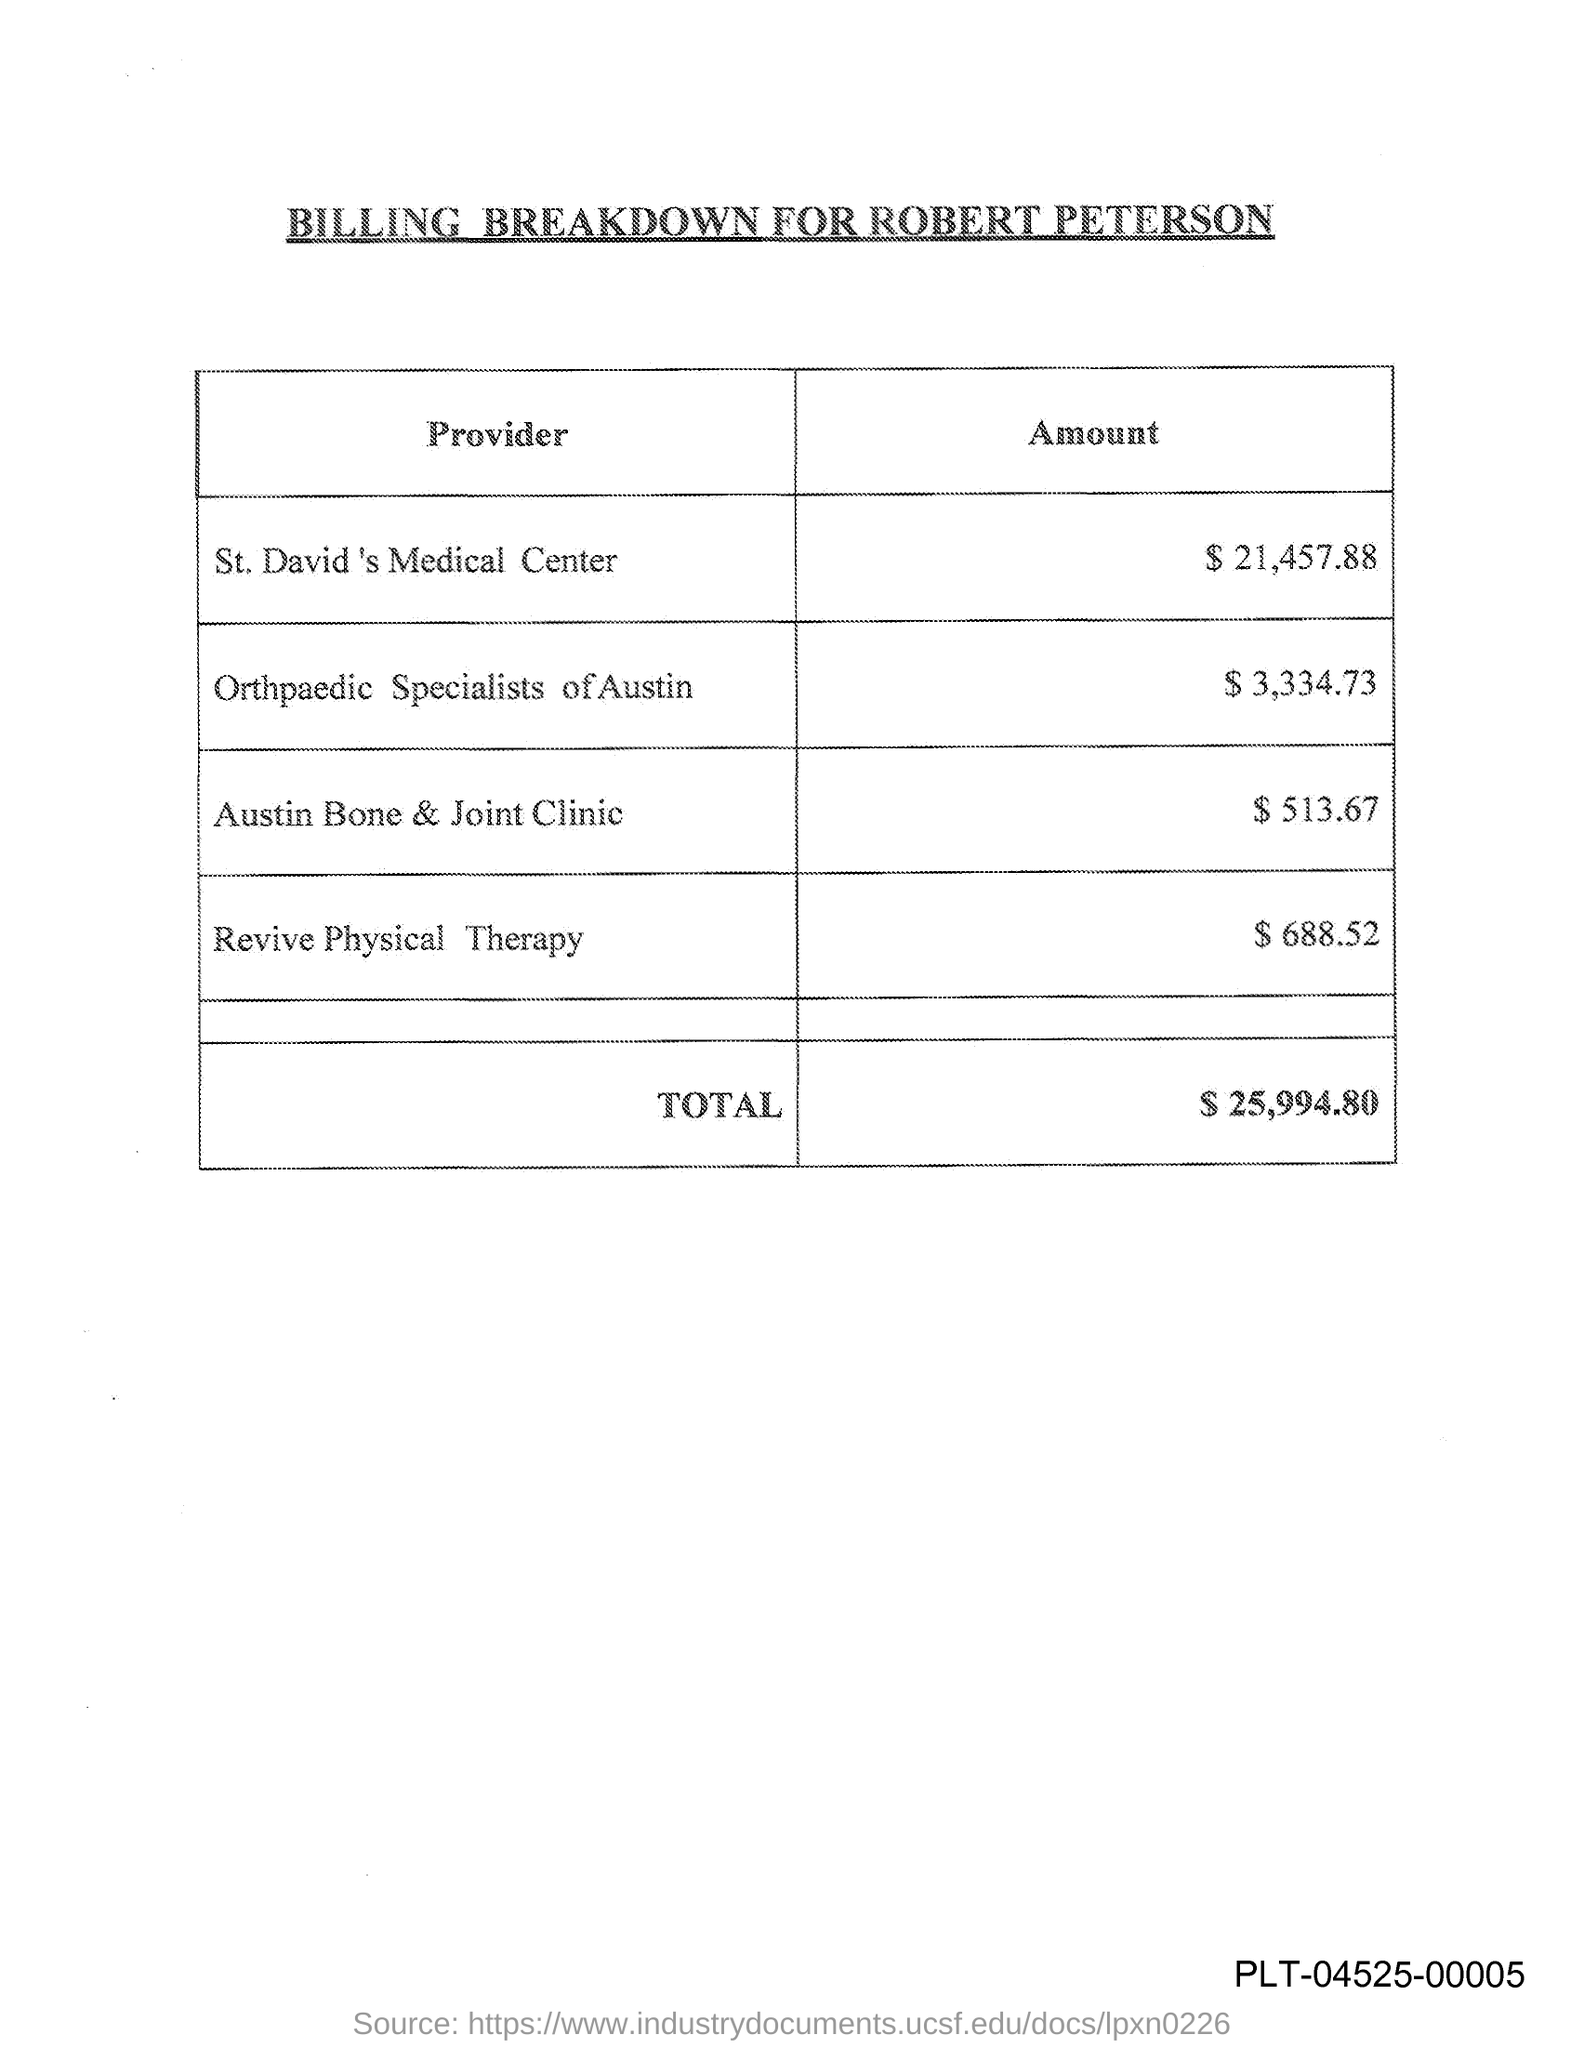What is the title of this document?
Your answer should be very brief. BILLING BREAKDOWN FOR ROBERT PETERSON. What is the amount provided by St. David's Medical Center?
Make the answer very short. $21,457.88. What is the amount provided by Revive Physical Therapy?
Ensure brevity in your answer.  $688.52. What is the amount provided by Orthopaedic Specialists of Austin?
Keep it short and to the point. $3,334.73. What is the total amount given in the document?
Make the answer very short. $25,994.80. What is the amount provided by Austin Bone & Joint Clinic?
Keep it short and to the point. $513.67. 